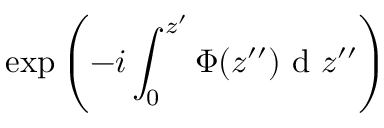<formula> <loc_0><loc_0><loc_500><loc_500>\exp \left ( - i \int _ { 0 } ^ { z ^ { \prime } } \Phi ( z ^ { \prime \prime } ) d z ^ { \prime \prime } \right )</formula> 